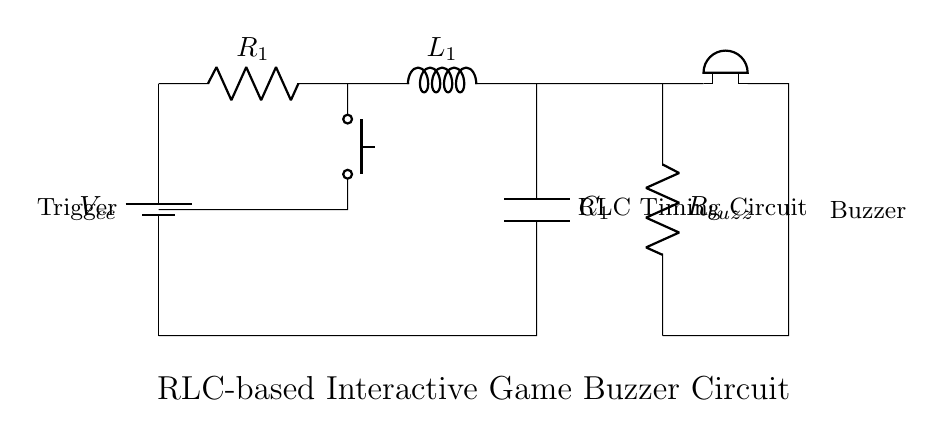What is the main function of the button in this circuit? The button serves as a trigger to initiate the operation of the circuit, allowing current to flow and activating the buzzer.
Answer: Trigger What type of circuit is this? This is an RLC circuit, consisting of a resistor, inductor, and capacitor, used for timing purposes.
Answer: RLC What is the role of the capacitor in the circuit? The capacitor stores electrical energy and influences the timing behavior of the circuit by controlling the charge and discharge cycles.
Answer: Storage How is the buzzer connected in relation to the RLC circuit? The buzzer is connected in series with a resistor and the output of the RLC circuit, allowing it to sound when the circuit is triggered.
Answer: Series What happens when the button is pressed? When the button is pressed, it completes the circuit, allowing current to flow through the RLC components, initiating a sound from the buzzer.
Answer: Sound What does the inductor do in this circuit? The inductor resists changes in current, affecting the timing and oscillation characteristics of the circuit.
Answer: Resists What is the total voltage provided by the battery? The total voltage provided is represented by Vcc; typically a value determined by the specific battery used, but not explicitly stated in the diagram.
Answer: Vcc 